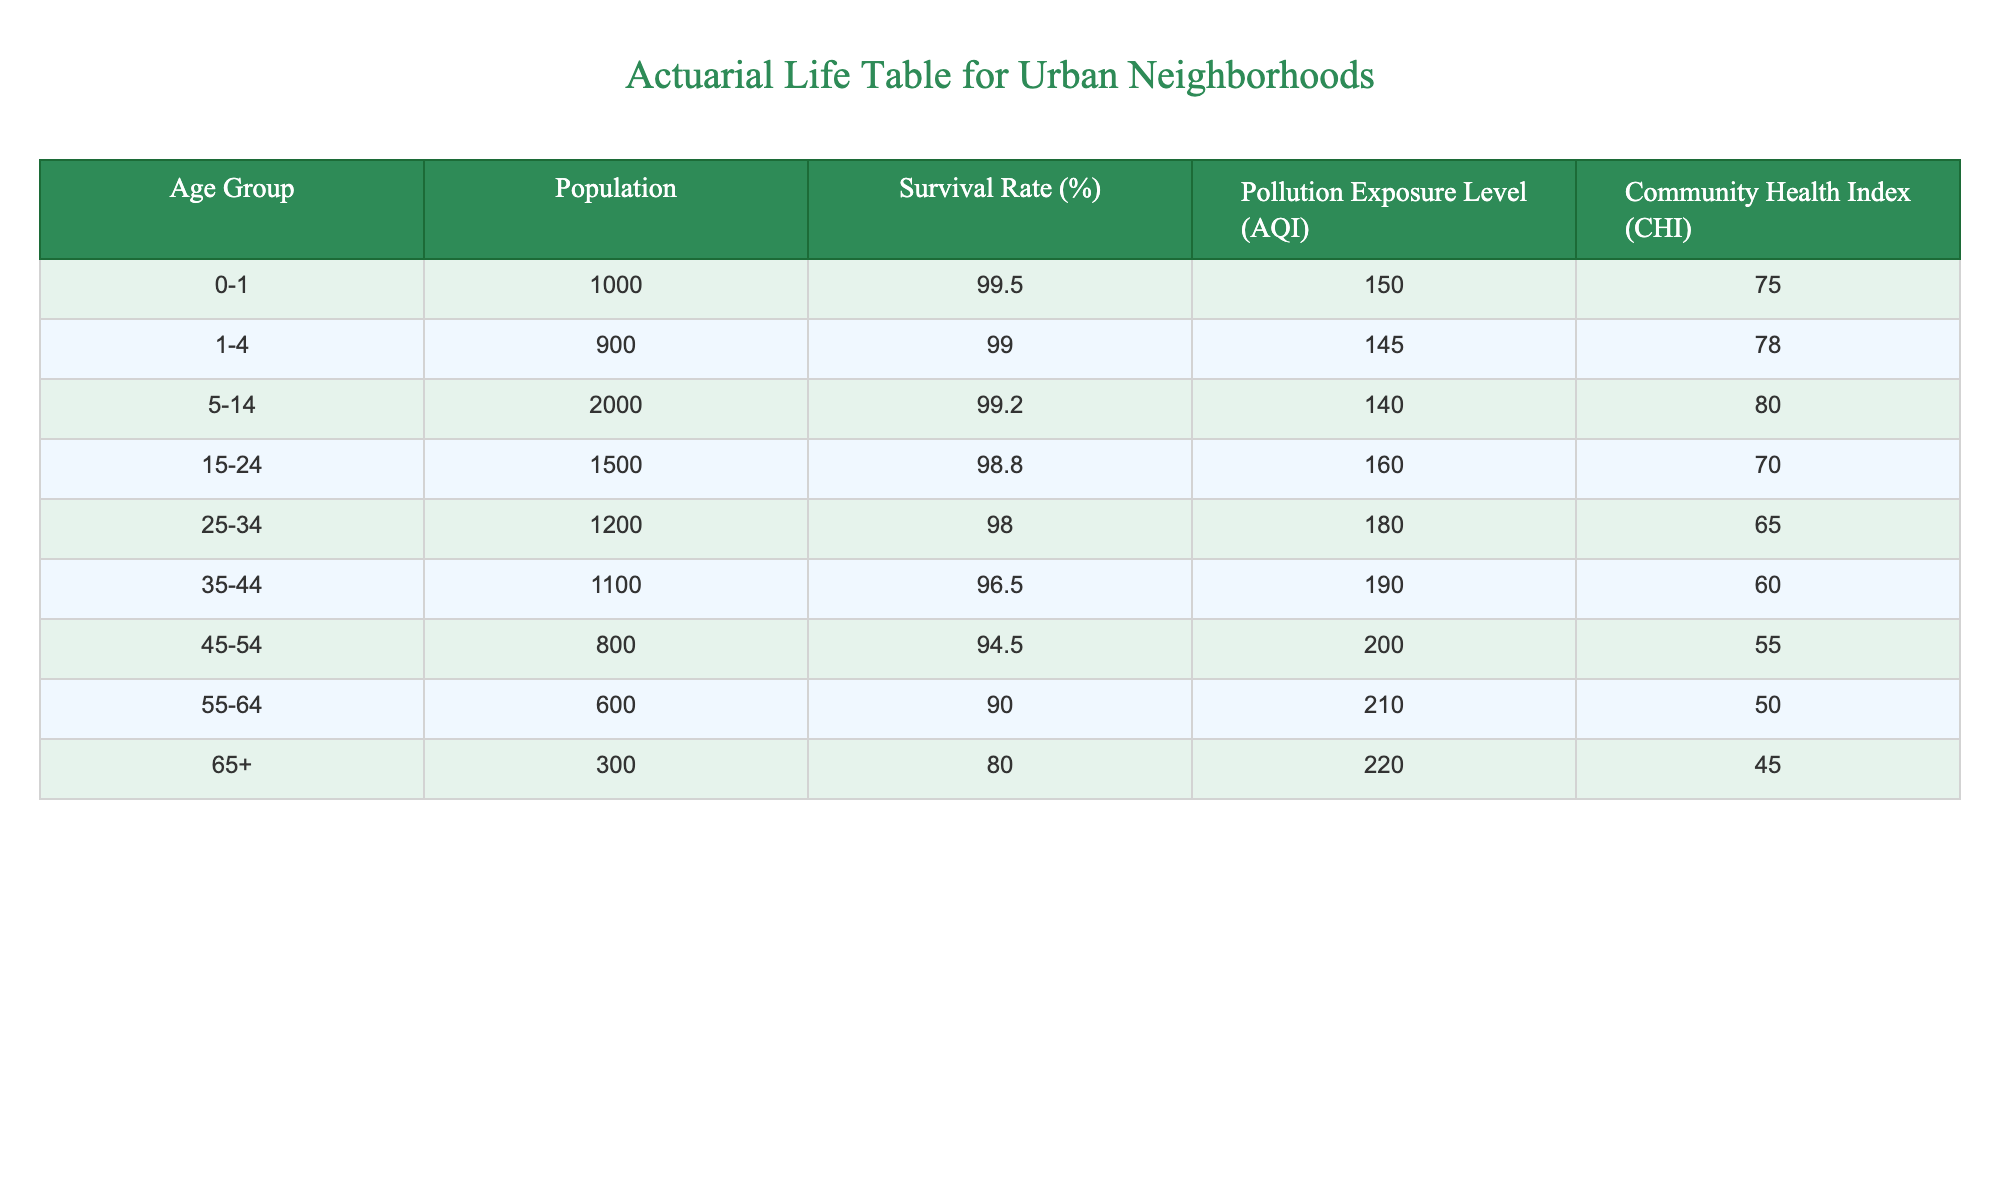What is the survival rate for the age group 55-64? You can find the survival rate for the age group 55-64 in the Survival Rate (%) column. It is directly listed as 90.0%.
Answer: 90.0% What is the Pollution Exposure Level (AQI) for the age group 35-44? The Pollution Exposure Level for the age group 35-44 is listed in the Pollution Exposure Level (AQI) column, which shows 190.
Answer: 190 Which age group has the lowest Community Health Index (CHI)? To determine this, we can look at the Community Health Index values for all age groups. The lowest value is seen in the 65+ age group at 45.
Answer: 45 What is the total population represented in the table? The total population can be calculated by summing the populations across all age groups: 1000 + 900 + 2000 + 1500 + 1200 + 1100 + 800 + 600 + 300 = 8300.
Answer: 8300 Is the survival rate for the age group 15-24 greater than 95%? The survival rate for the age group 15-24 is 98.8%, which is indeed greater than 95%. Therefore, the answer is yes.
Answer: Yes What is the average pollution exposure level across the age groups listed? To calculate the average pollution exposure, we add all AQI values: 150 + 145 + 140 + 160 + 180 + 190 + 200 + 210 + 220 = 1895, and then divide by the number of groups, which is 9: 1895 / 9 ≈ 210.56.
Answer: 210.56 Does the Community Health Index improve as the Pollution Exposure Level decreases? To assess this, we compare the AQI and CHI values. A general observation shows that as the AQI value decreases, the CHI tends to increase for the age groups. Hence, the statement seems true.
Answer: True What is the difference in survival rates between the 0-1 age group and the 45-54 age group? The survival rate for the 0-1 age group is 99.5%, and for the 45-54 age group, it is 94.5%. Therefore, the difference is 99.5 - 94.5 = 5.0%.
Answer: 5.0% Which age group experiences the highest level of pollution exposure? By reviewing the Pollution Exposure Level column, the highest value is found in the 65+ age group at 220.
Answer: 220 